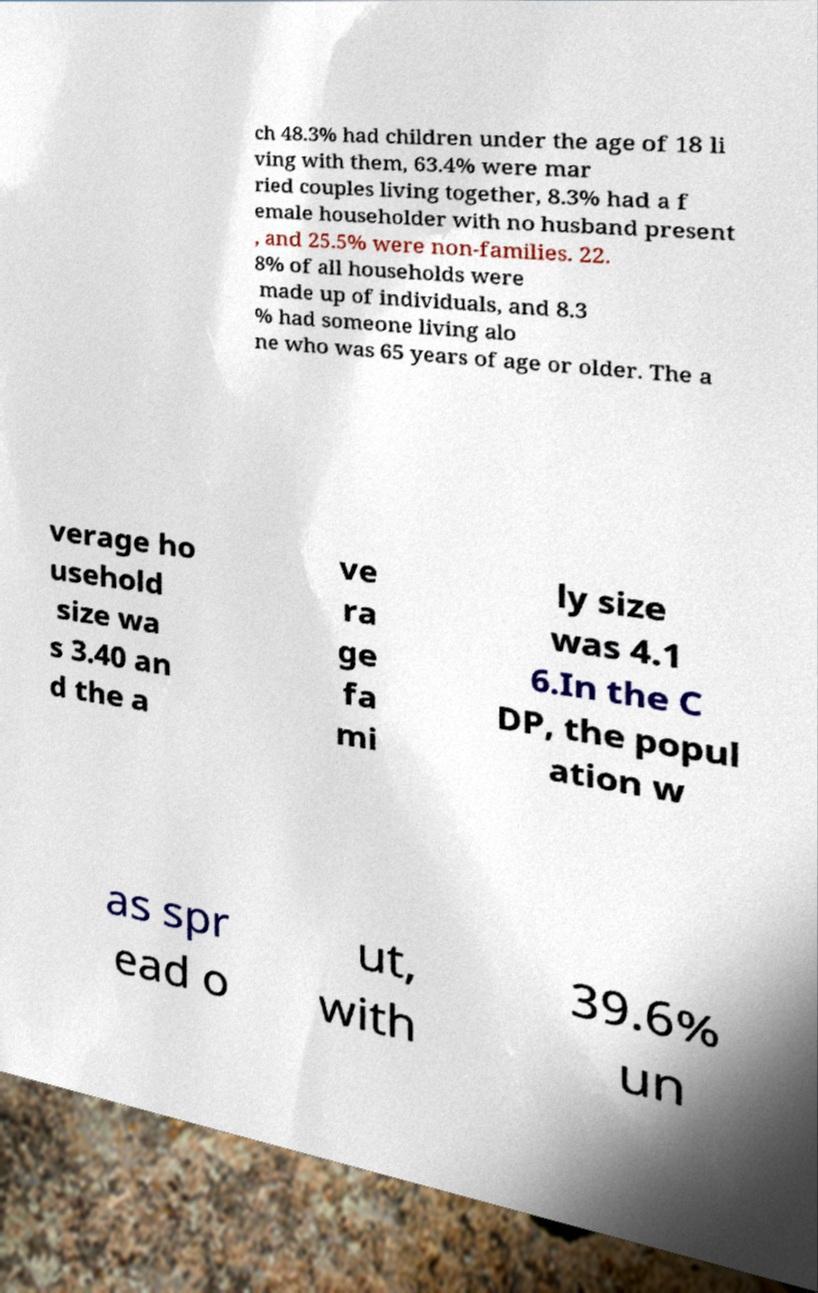What messages or text are displayed in this image? I need them in a readable, typed format. ch 48.3% had children under the age of 18 li ving with them, 63.4% were mar ried couples living together, 8.3% had a f emale householder with no husband present , and 25.5% were non-families. 22. 8% of all households were made up of individuals, and 8.3 % had someone living alo ne who was 65 years of age or older. The a verage ho usehold size wa s 3.40 an d the a ve ra ge fa mi ly size was 4.1 6.In the C DP, the popul ation w as spr ead o ut, with 39.6% un 